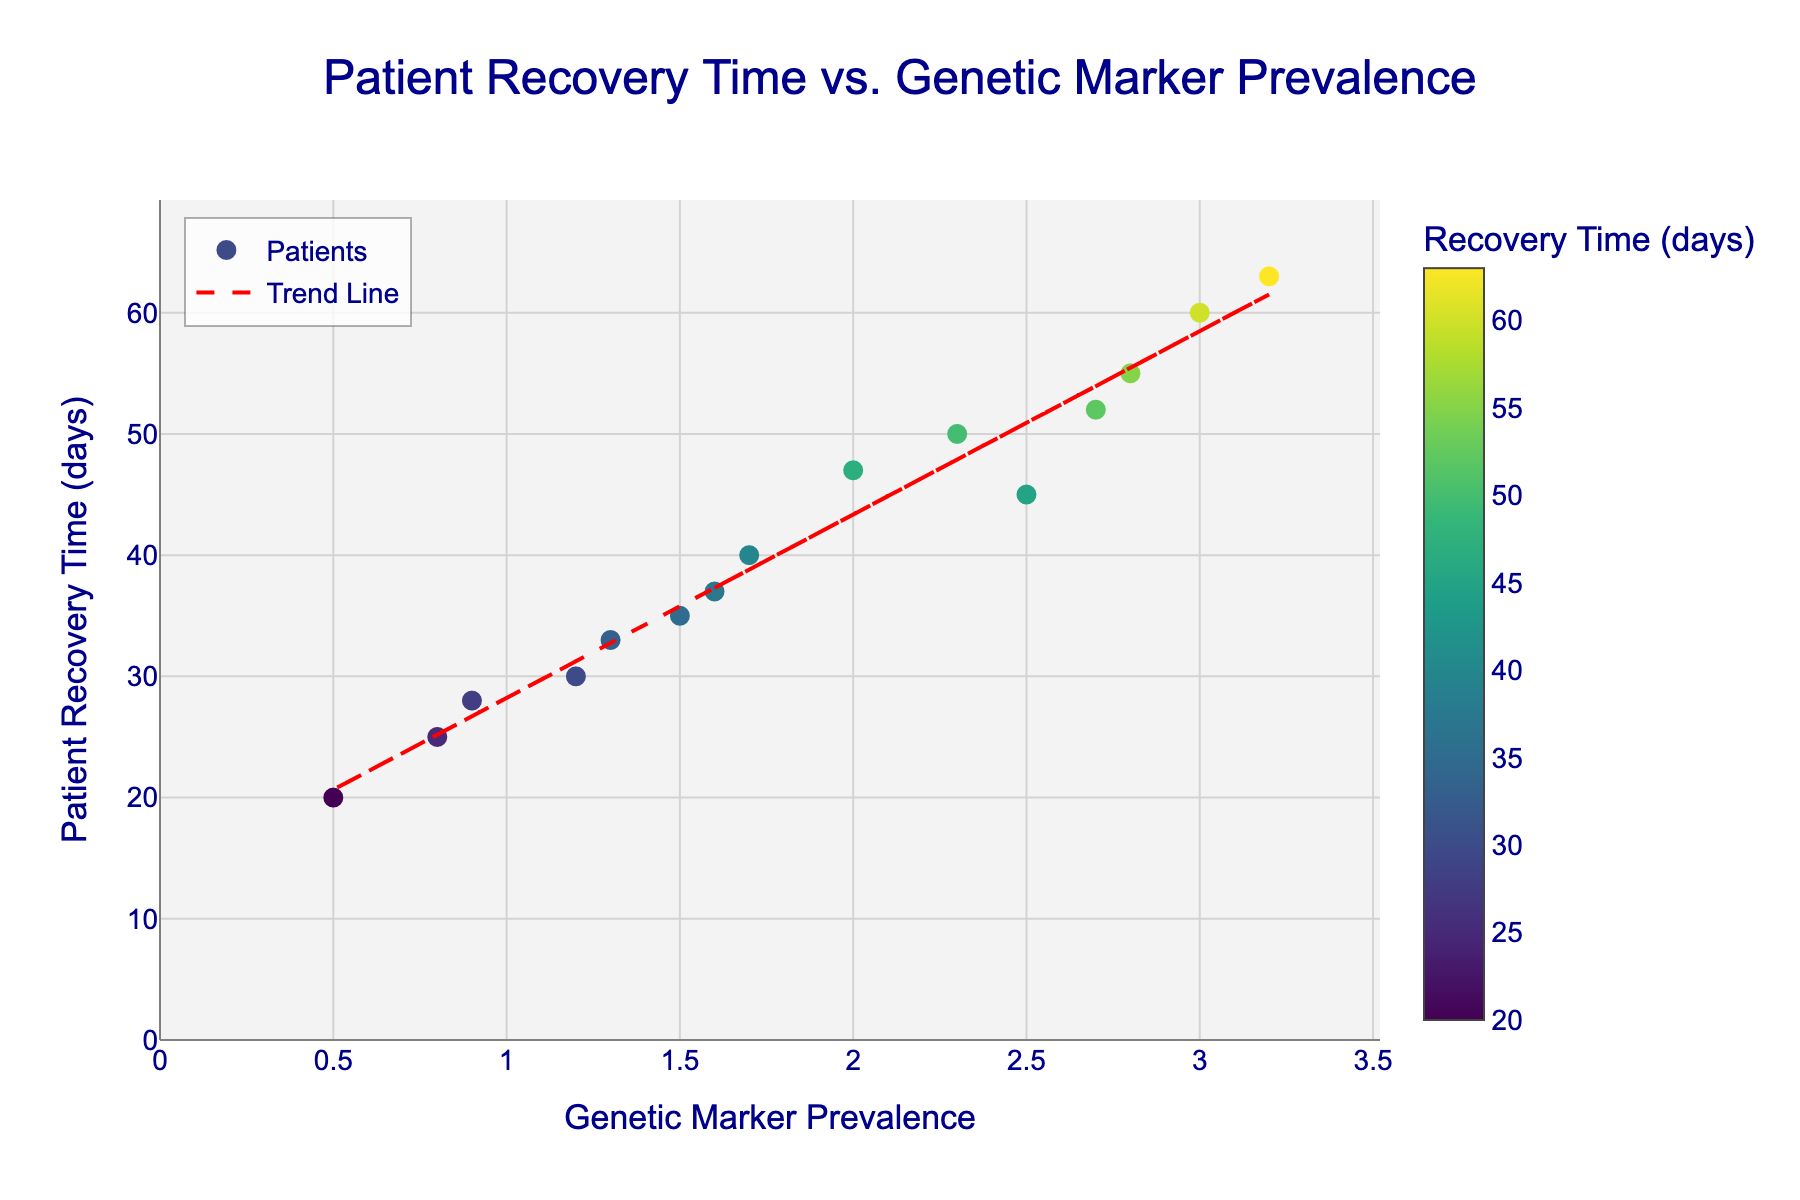What's the title of the figure? The title of the figure is displayed at the top and it reads "Patient Recovery Time vs. Genetic Marker Prevalence".
Answer: Patient Recovery Time vs. Genetic Marker Prevalence How many data points are shown in the scatter plot? By counting the number of markers in the scatter plot, we can see there are 15 data points.
Answer: 15 What does the color of the markers represent? The color of the markers is shown on a color scale that represents Patient Recovery Time, with different colors indicating different recovery durations.
Answer: Patient Recovery Time What are the axes labels of the figure? The x-axis label is "Genetic Marker Prevalence" and the y-axis label is "Patient Recovery Time (days)". These labels are shown along the respective axes of the plot.
Answer: Genetic Marker Prevalence (x-axis), Patient Recovery Time (days) (y-axis) What is the general trend indicated by the trend line? The trend line is sloping upwards as we move from left to right, indicating a positive correlation between Genetic Marker Prevalence and Patient Recovery Time. This means that as Genetic Marker Prevalence increases, Patient Recovery Time also tends to increase.
Answer: Positive correlation Which patient had the longest recovery time and what is their genetic marker prevalence? The patient with the longest recovery time is represented by the highest point on the y-axis in the scatter plot. This point corresponds to a recovery time of 63 days and a genetic marker prevalence of 3.2.
Answer: Recovery time: 63 days, Genetic marker prevalence: 3.2 Compare the recovery times of patients with genetic marker prevalence of 1.5 and 2.3. Which is higher? By locating the points corresponding to genetic marker prevalence of 1.5 and 2.3 on the x-axis and comparing their y-values (recovery times), we see that the patient with a genetic marker prevalence of 1.5 has a recovery time of 35 days, whereas the one with 2.3 has a recovery time of 50 days. Thus, the recovery time for 2.3 is higher.
Answer: 2.3 What is the average recovery time of patients with a genetic marker prevalence below 1.0? First, identify the patients with a genetic marker prevalence below 1.0 (0.8, 0.5, 0.9). Their recovery times are 25, 20, and 28 days respectively. To find the average, sum these times (25 + 20 + 28 = 73) and divide by the number of patients (3). The average recovery time is 73 / 3 = 24.33 days.
Answer: 24.33 days Do all patients follow the trend indicated by the trend line? While the trend line indicates a general upward trend, there are data points both above and below the trend line, indicating that not all patients follow the exact trend. There are variations in recovery times for the same or similar genetic marker prevalence values.
Answer: No 